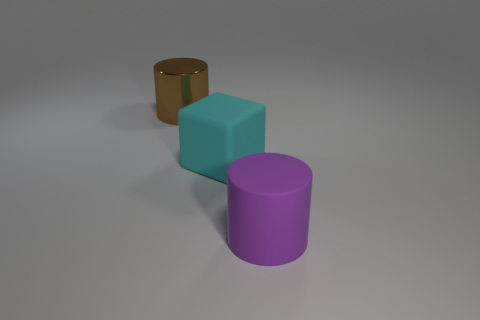Is there another purple cylinder of the same size as the metallic cylinder?
Provide a succinct answer. Yes. There is a rubber thing that is in front of the rubber cube; does it have the same size as the big cyan block?
Your response must be concise. Yes. There is a big thing that is both in front of the big shiny thing and behind the purple matte cylinder; what shape is it?
Make the answer very short. Cube. Are there more large purple rubber objects behind the cyan rubber object than red shiny spheres?
Your answer should be compact. No. What is the size of the purple thing that is the same material as the cyan object?
Offer a terse response. Large. What number of big rubber cubes are the same color as the large shiny cylinder?
Offer a very short reply. 0. There is a large cylinder behind the large purple rubber cylinder; does it have the same color as the rubber cylinder?
Keep it short and to the point. No. Are there the same number of large cyan objects in front of the cyan matte thing and things behind the large purple rubber cylinder?
Your answer should be compact. No. Are there any other things that have the same material as the brown object?
Make the answer very short. No. The large cylinder that is on the right side of the large brown cylinder is what color?
Your answer should be compact. Purple. 